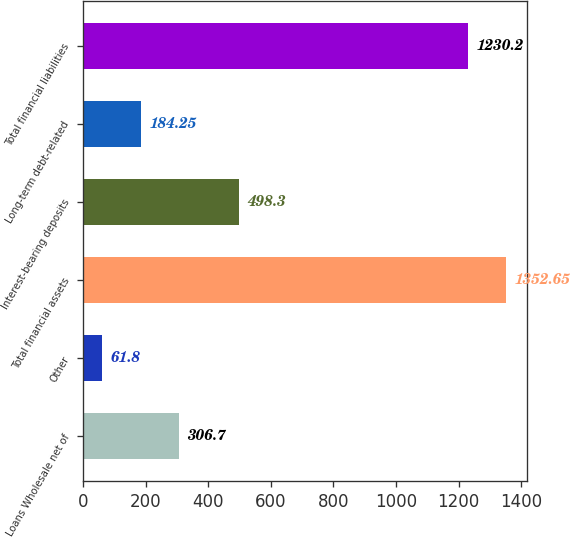<chart> <loc_0><loc_0><loc_500><loc_500><bar_chart><fcel>Loans Wholesale net of<fcel>Other<fcel>Total financial assets<fcel>Interest-bearing deposits<fcel>Long-term debt-related<fcel>Total financial liabilities<nl><fcel>306.7<fcel>61.8<fcel>1352.65<fcel>498.3<fcel>184.25<fcel>1230.2<nl></chart> 